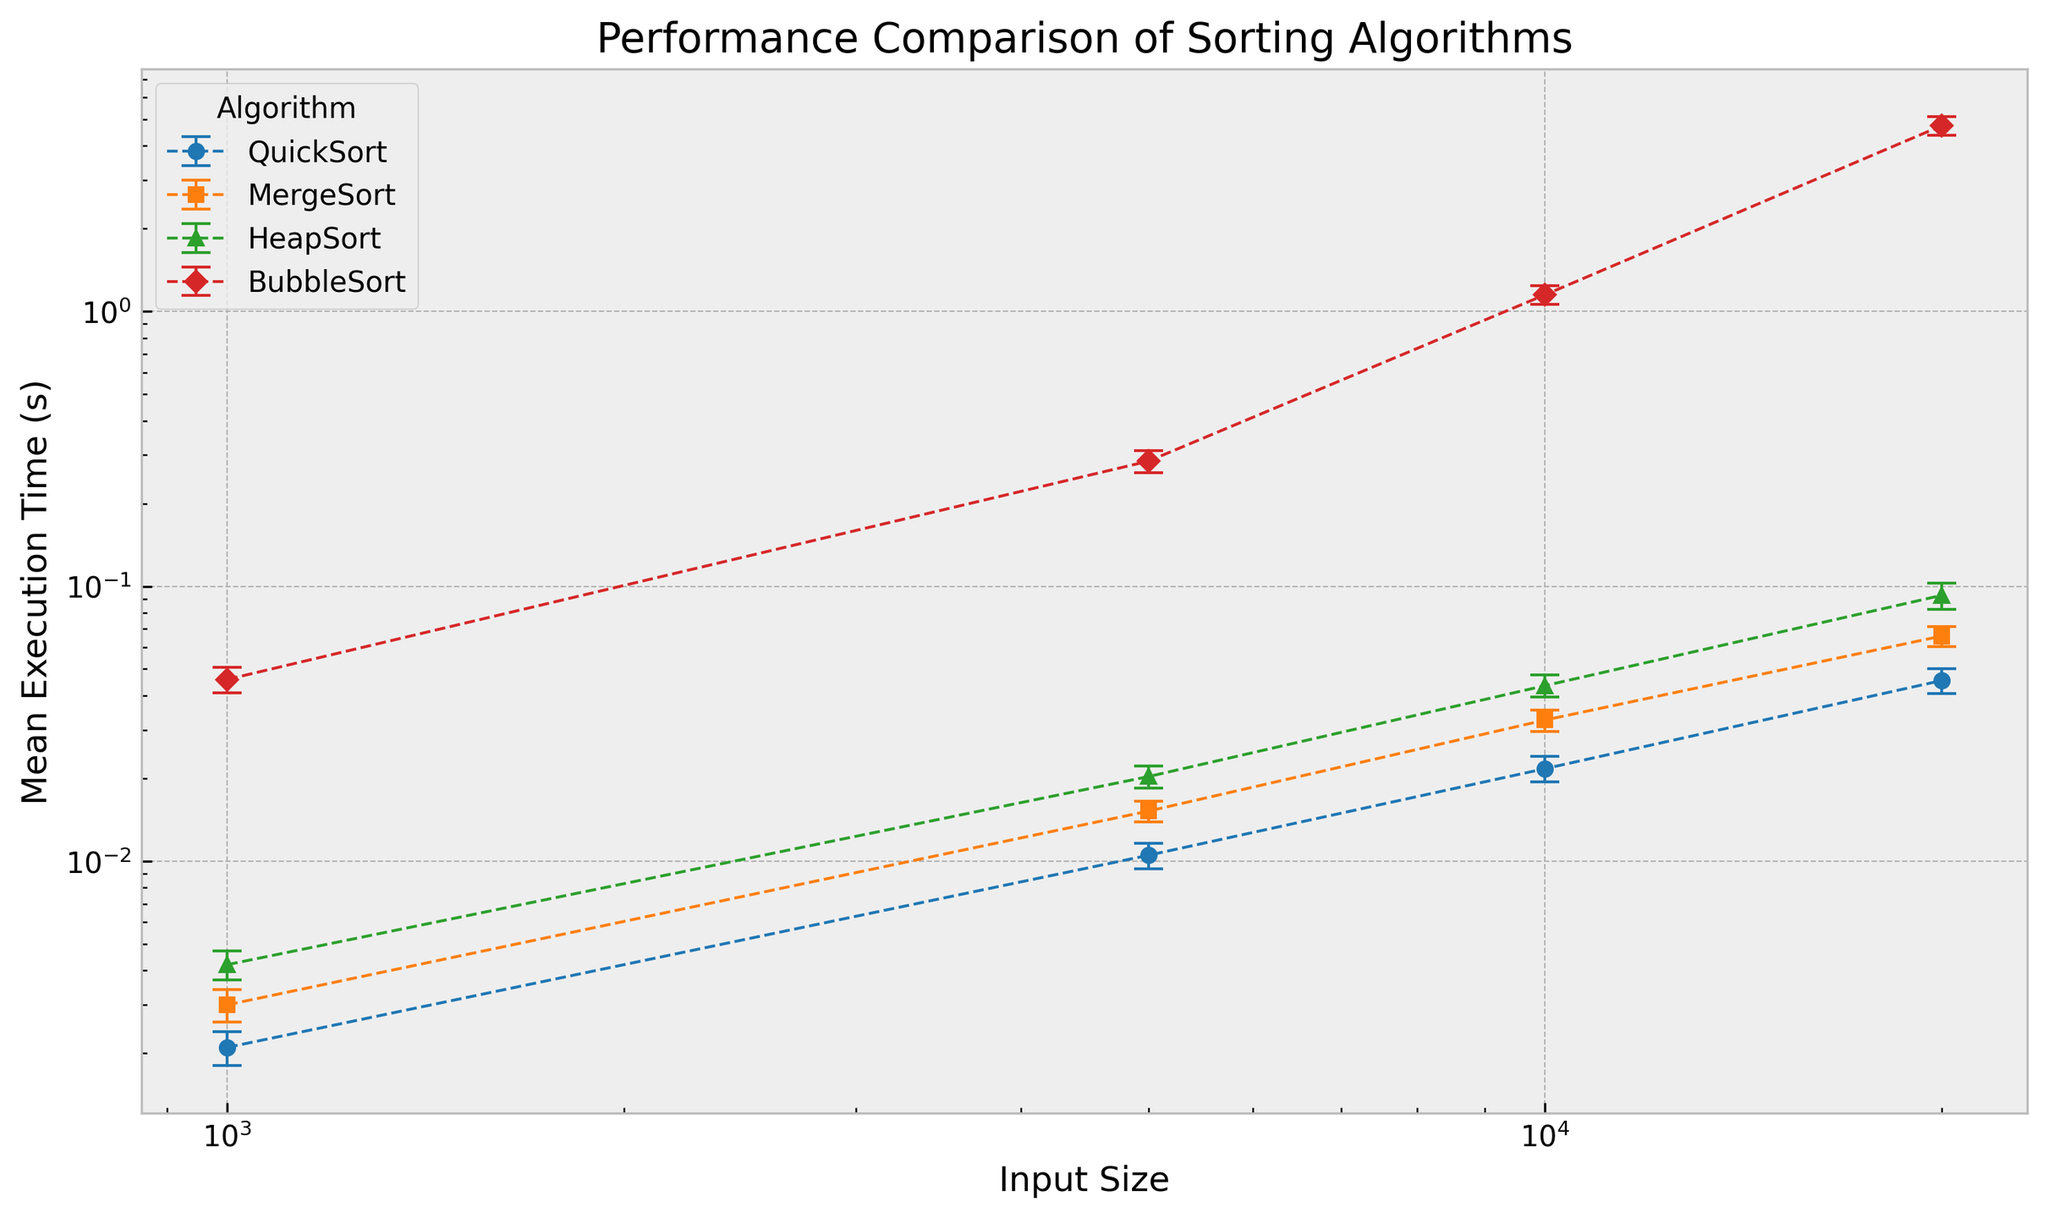Which algorithm has the smallest mean execution time for an input size of 20,000? To determine the smallest mean execution time for input size 20,000, we compare the values for all algorithms. QuickSort has 0.0454s, MergeSort has 0.0659s, HeapSort has 0.0927s, and BubbleSort has 4.7391s. QuickSort has the smallest mean execution time.
Answer: QuickSort How does the performance of BubbleSort for input size 5000 compare to the performance of HeapSort for input size 20000? BubbleSort at input size 5000 has a mean execution time of 0.2851s with a standard deviation of 0.0270s. HeapSort at input size 20000 has a mean execution time of 0.0927s with a standard deviation of 0.0102s. BubbleSort takes longer to execute compared to HeapSort.
Answer: BubbleSort is slower Which algorithm shows the largest standard deviation for input size 10,000? To find the largest standard deviation for input size 10,000, we compare the values for all algorithms. QuickSort has 0.0023s, MergeSort has 0.0029s, HeapSort has 0.0040s, and BubbleSort has 0.0904s. BubbleSort has the largest standard deviation.
Answer: BubbleSort What is the difference in mean execution time between QuickSort and MergeSort for input size 1000? QuickSort has a mean execution time of 0.0021s and MergeSort has 0.0030s for input size 1000. The difference is 0.0030 - 0.0021 = 0.0009s.
Answer: 0.0009s For input size 5000, which algorithm has the smallest standard deviation and what is its value? For input size 5000, we compare standard deviations: QuickSort has 0.0011s, MergeSort has 0.0013s, HeapSort has 0.0019s, and BubbleSort has 0.0270s. QuickSort has the smallest standard deviation of 0.0011s.
Answer: QuickSort, 0.0011s How does the performance curve of BubbleSort visually compare to that of QuickSort across different input sizes? Visually, BubbleSort's performance curve shows a steep increase in execution time as input size increases, while QuickSort shows a more gradual increase. BubbleSort's line ascends sharply, indicating poor scalability.
Answer: BubbleSort's curve increases more sharply What is the average of the mean execution times for MergeSort across all input sizes? MergeSort's mean execution times are 0.0030s, 0.0152s, 0.0326s, and 0.0659s. The average is (0.0030 + 0.0152 + 0.0326 + 0.0659) / 4 = 0.029175s.
Answer: 0.029175s If the input size doubles from 10,000 to 20,000, which algorithm shows the greatest increase in mean execution time? We calculate the increase in mean execution time for each algorithm when input size doubles from 10,000 to 20,000. QuickSort: 0.0454 - 0.0217 = 0.0237s, MergeSort: 0.0659 - 0.0326 = 0.0333s, HeapSort: 0.0927 - 0.0435 = 0.0492s, BubbleSort: 4.7391 - 1.1496 = 3.5895s. BubbleSort shows the greatest increase.
Answer: BubbleSort 